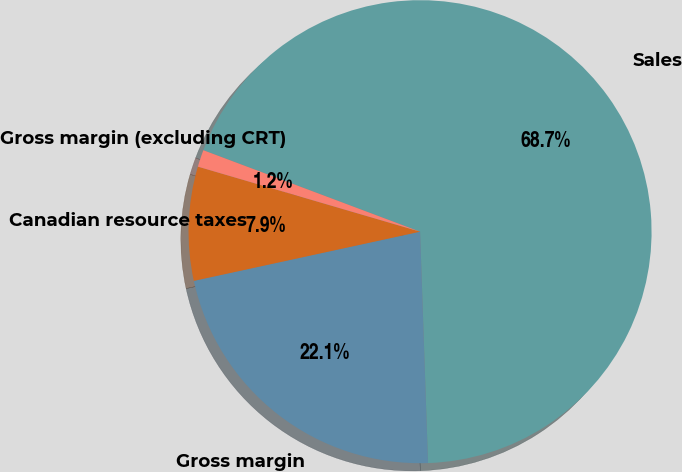<chart> <loc_0><loc_0><loc_500><loc_500><pie_chart><fcel>Sales<fcel>Gross margin<fcel>Canadian resource taxes<fcel>Gross margin (excluding CRT)<nl><fcel>68.73%<fcel>22.14%<fcel>7.94%<fcel>1.19%<nl></chart> 